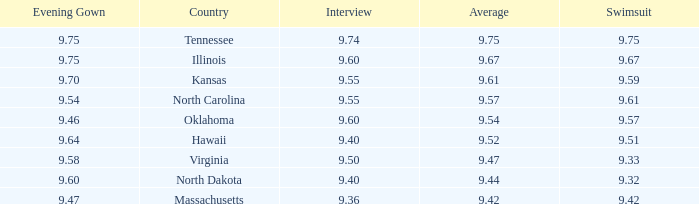What was hawaii's interview score? 9.4. 